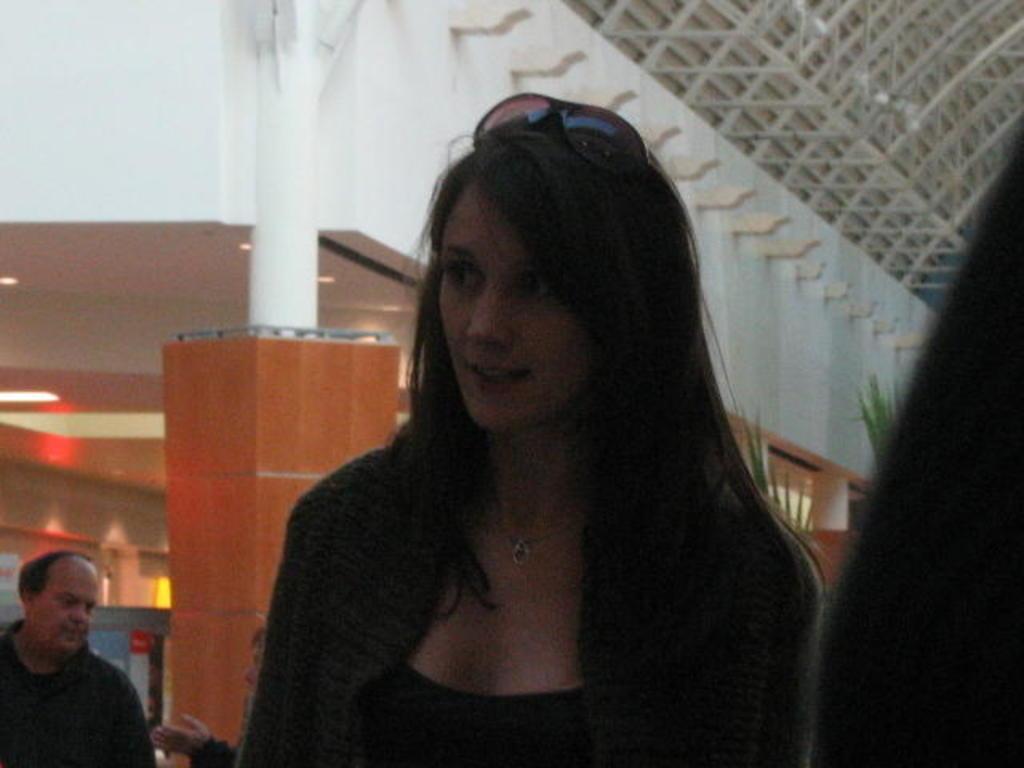Describe this image in one or two sentences. In this image, we can see a woman. Background we can see pillars, ceiling, lights, walls and rods. On the left side bottom, we can see people and few objects. 